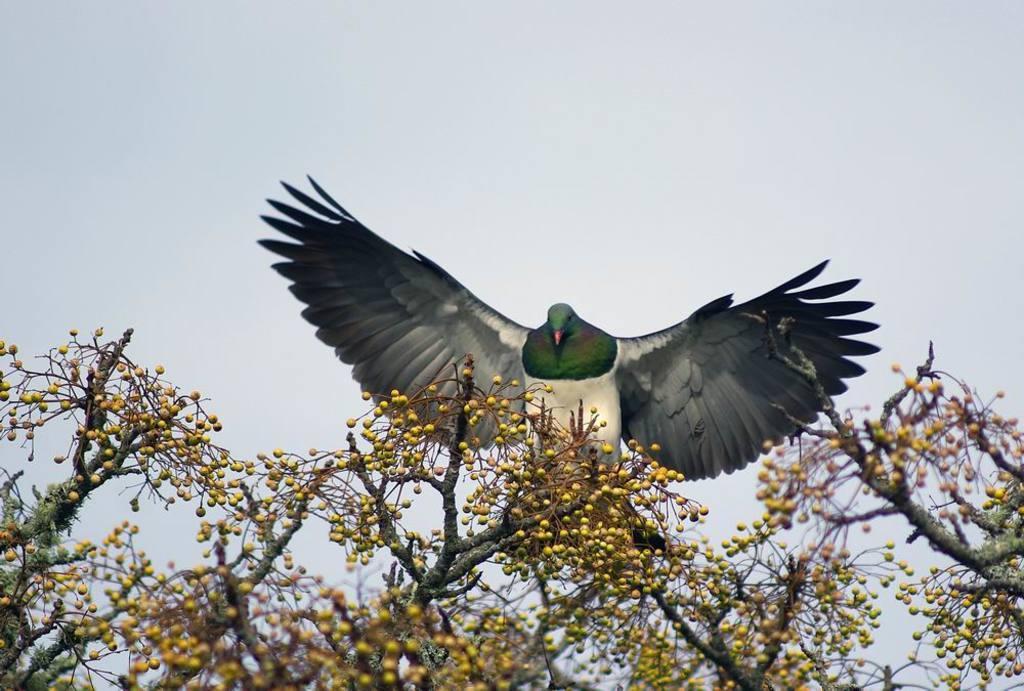Can you describe this image briefly? At the bottom of the image. We can see branches of trees with seeds. And there is a bird flying. In the background there is sky. 